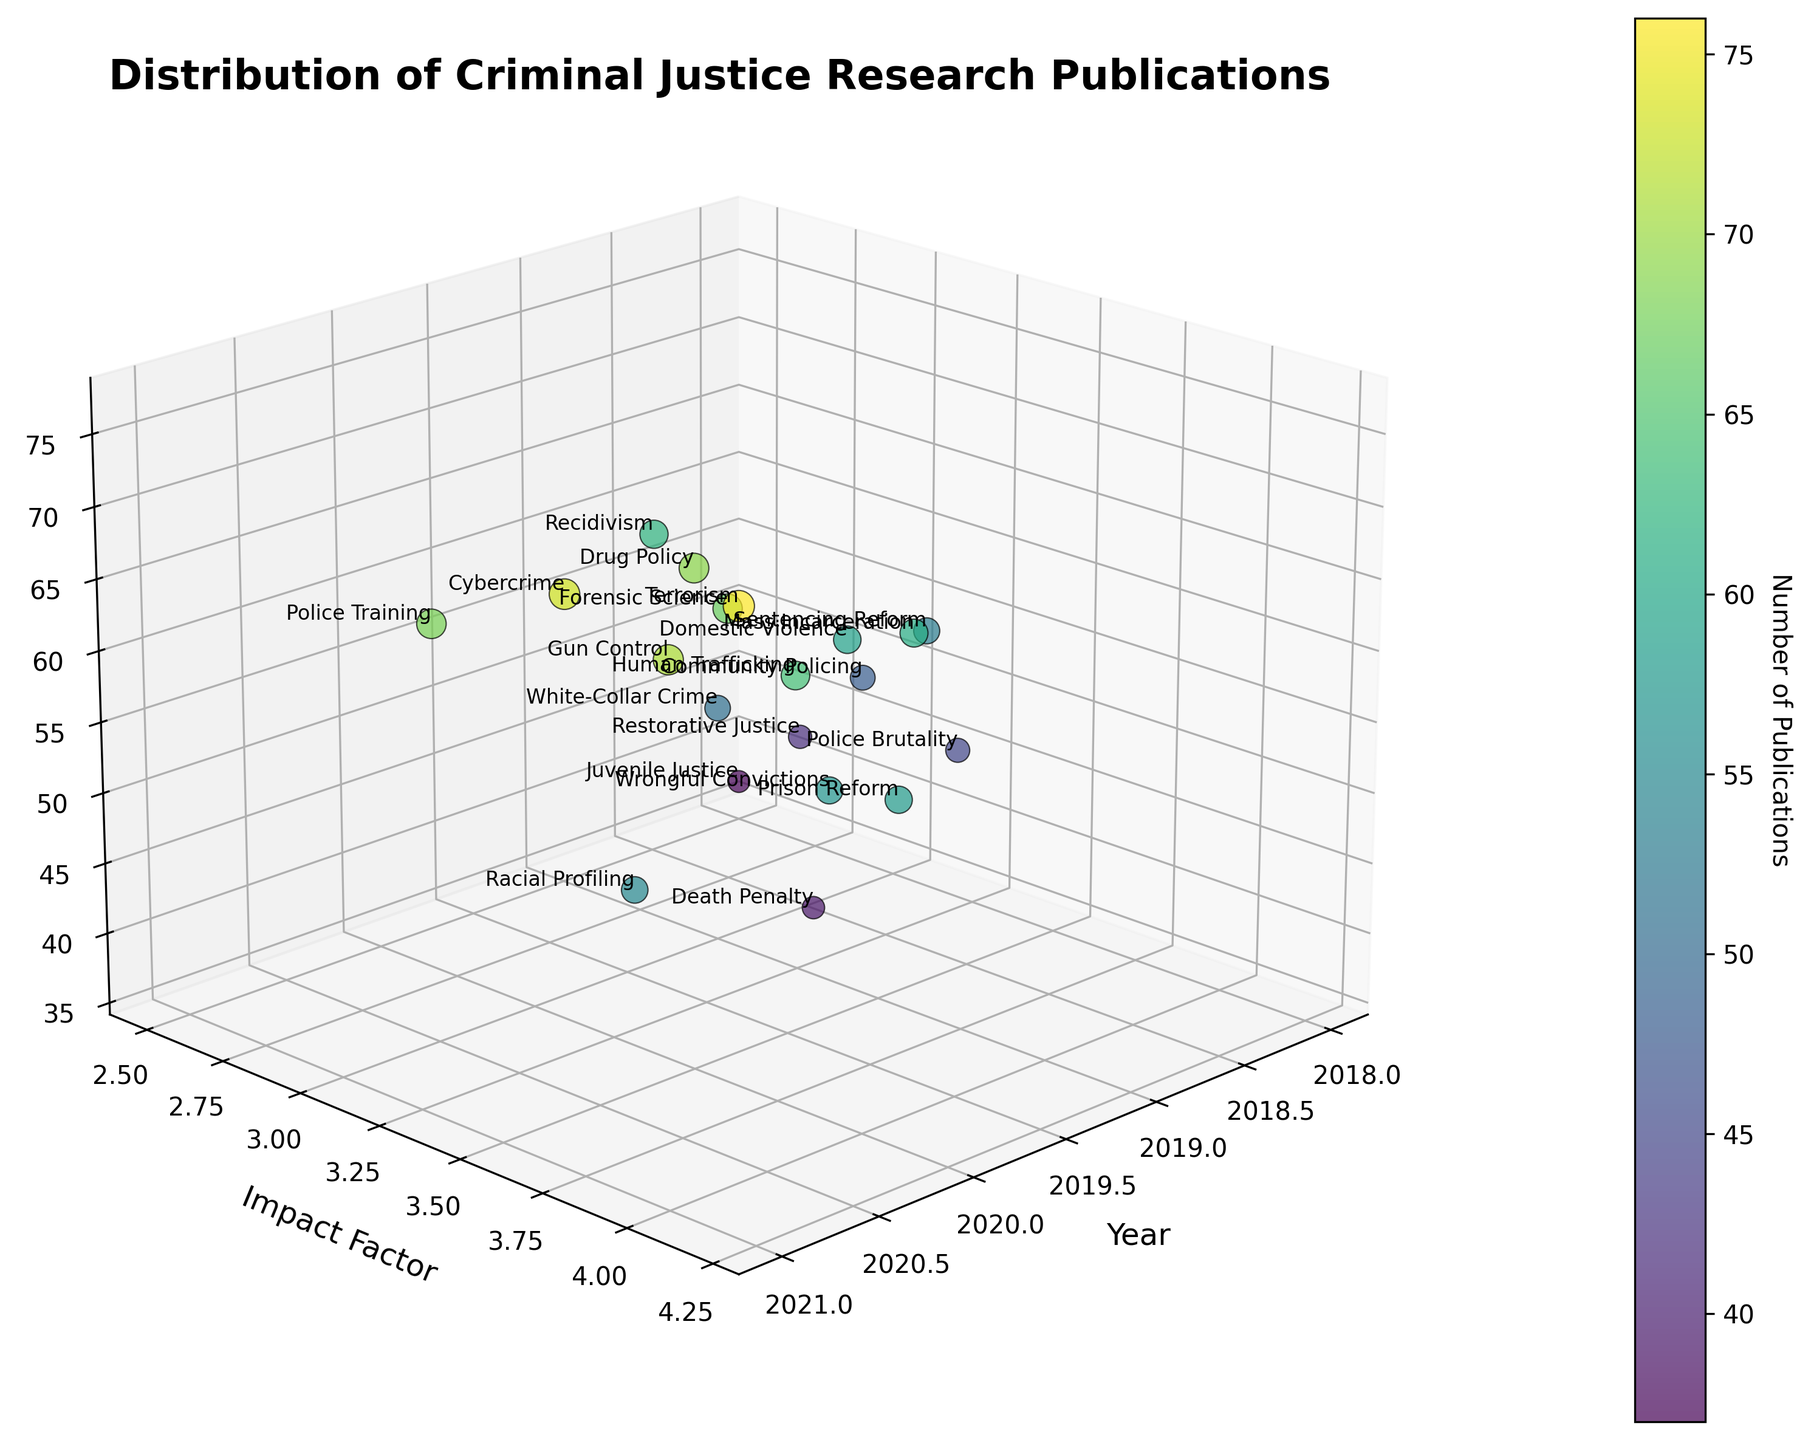what is the title of the figure? The title is usually located at the top center of the figure. In this case, it's clearly written and specifies the content of the plot.
Answer: Distribution of Criminal Justice Research Publications What year has the highest number of publications for Cybercrime? By looking at the year and number of publications for the topic Cybercrime, you can see it is marked for the year 2021 with a publication count of 73.
Answer: 2021 What is the average impact factor for publications in the year 2020? The impact factors for 2020 are 4.1, 3.5, 3.8, 3.6, 3.9 which sum to 18.9. Dividing this by the number of data points (5) gives an average of 18.9/5.
Answer: 3.78 Which topic had the least number of publications in 2018? Reviewing the data points for 2018, Juvenile Justice had the lowest number with 37 publications, the rest having higher counts.
Answer: Juvenile Justice Which topic has the highest impact factor and what is its value? The highest impact factor can be identified by looking at the 'Impact Factor' axis and finding the peak value of 4.2, which corresponds to the topic Terrorism in 2021.
Answer: Terrorism, 4.2 How many publications had an impact factor above 3.5 in the year 2019? By filtering the data points for 2019 and counting those exceeding a 3.5 impact factor, only Domestic Violence and Mass Incarceration meet the criteria.
Answer: 2 Compare the number of publications for Prison Reform and Sentencing Reform in their respective years. Which has more? Prison Reform in 2020 had 58 publications, while Sentencing Reform in 2018 had 53 publications. Prison Reform had more.
Answer: Prison Reform Which year had the highest number of publications collectively and what is the total count? Summing the number of publications for each year, 2021 has the highest total with 73 + 55 + 71 + 76 + 68 = 343 publications.
Answer: 2021, 343 For the topic of Restorative Justice, what is the publication count and impact factor for its year? Referring to the plotted data, Restorative Justice in 2018 had a publication count of 42 and an impact factor of 2.7.
Answer: 42 publications, 2.7 impact factor What is the trend in the number of publications for the years 2018 to 2021? By visually analyzing the scatter data points from 2018 through 2021, the number of publications generally increases over these years, indicating a rising trend.
Answer: Rising trend 